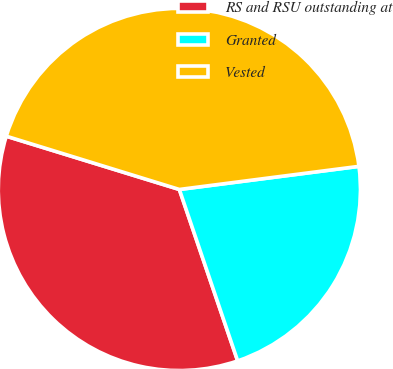<chart> <loc_0><loc_0><loc_500><loc_500><pie_chart><fcel>RS and RSU outstanding at<fcel>Granted<fcel>Vested<nl><fcel>34.97%<fcel>21.82%<fcel>43.21%<nl></chart> 